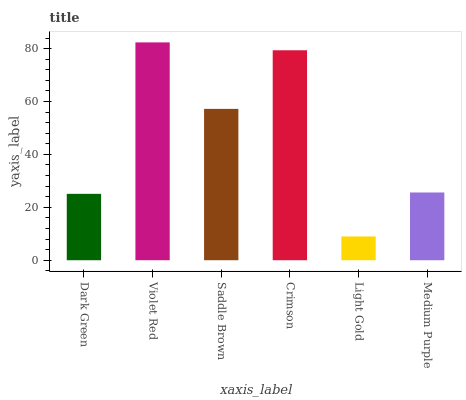Is Light Gold the minimum?
Answer yes or no. Yes. Is Violet Red the maximum?
Answer yes or no. Yes. Is Saddle Brown the minimum?
Answer yes or no. No. Is Saddle Brown the maximum?
Answer yes or no. No. Is Violet Red greater than Saddle Brown?
Answer yes or no. Yes. Is Saddle Brown less than Violet Red?
Answer yes or no. Yes. Is Saddle Brown greater than Violet Red?
Answer yes or no. No. Is Violet Red less than Saddle Brown?
Answer yes or no. No. Is Saddle Brown the high median?
Answer yes or no. Yes. Is Medium Purple the low median?
Answer yes or no. Yes. Is Dark Green the high median?
Answer yes or no. No. Is Violet Red the low median?
Answer yes or no. No. 